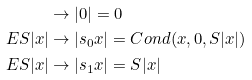Convert formula to latex. <formula><loc_0><loc_0><loc_500><loc_500>& \rightarrow | 0 | = 0 \\ E S | x | & \rightarrow | s _ { 0 } x | = C o n d ( x , 0 , S | x | ) \\ E S | x | & \rightarrow | s _ { 1 } x | = S | x |</formula> 